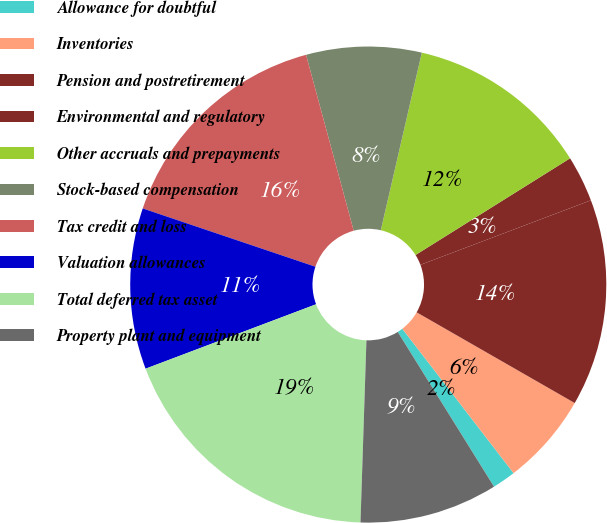Convert chart. <chart><loc_0><loc_0><loc_500><loc_500><pie_chart><fcel>Allowance for doubtful<fcel>Inventories<fcel>Pension and postretirement<fcel>Environmental and regulatory<fcel>Other accruals and prepayments<fcel>Stock-based compensation<fcel>Tax credit and loss<fcel>Valuation allowances<fcel>Total deferred tax asset<fcel>Property plant and equipment<nl><fcel>1.59%<fcel>6.26%<fcel>14.05%<fcel>3.14%<fcel>12.49%<fcel>7.82%<fcel>15.61%<fcel>10.93%<fcel>18.73%<fcel>9.38%<nl></chart> 